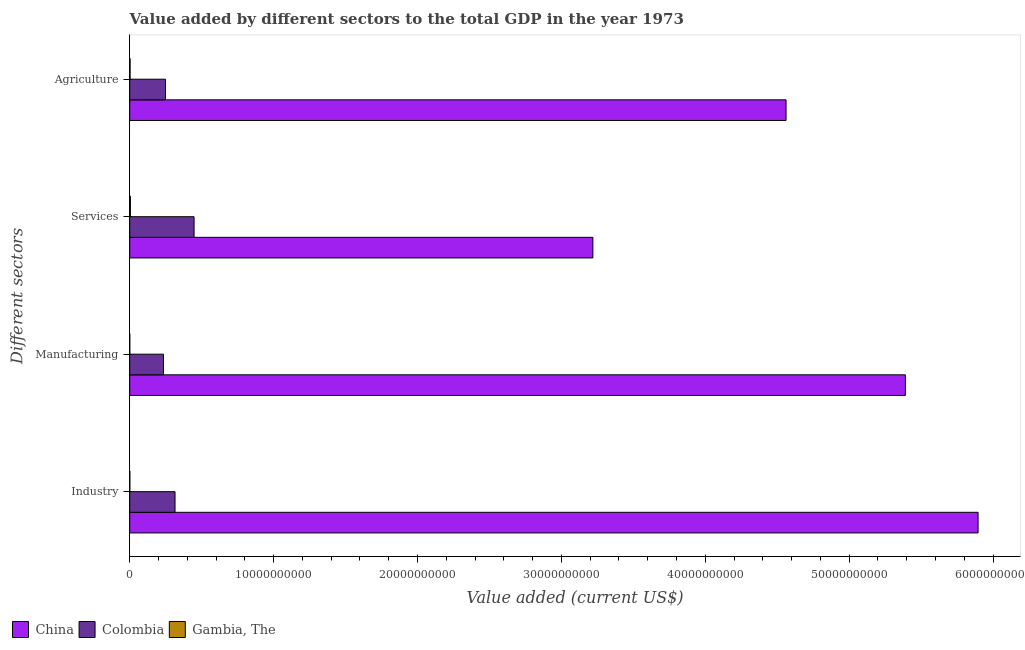How many different coloured bars are there?
Provide a succinct answer. 3. How many groups of bars are there?
Ensure brevity in your answer.  4. Are the number of bars on each tick of the Y-axis equal?
Offer a terse response. Yes. What is the label of the 2nd group of bars from the top?
Offer a terse response. Services. What is the value added by manufacturing sector in Gambia, The?
Your answer should be very brief. 2.20e+06. Across all countries, what is the maximum value added by agricultural sector?
Offer a very short reply. 4.56e+1. Across all countries, what is the minimum value added by agricultural sector?
Provide a succinct answer. 2.42e+07. In which country was the value added by manufacturing sector minimum?
Make the answer very short. Gambia, The. What is the total value added by manufacturing sector in the graph?
Your answer should be very brief. 5.63e+1. What is the difference between the value added by services sector in China and that in Colombia?
Give a very brief answer. 2.77e+1. What is the difference between the value added by manufacturing sector in Gambia, The and the value added by services sector in Colombia?
Make the answer very short. -4.47e+09. What is the average value added by industrial sector per country?
Offer a very short reply. 2.07e+1. What is the difference between the value added by agricultural sector and value added by services sector in Gambia, The?
Offer a very short reply. -2.05e+07. What is the ratio of the value added by manufacturing sector in Gambia, The to that in China?
Your answer should be very brief. 4.085952484394732e-5. Is the value added by manufacturing sector in Gambia, The less than that in China?
Make the answer very short. Yes. Is the difference between the value added by agricultural sector in Gambia, The and China greater than the difference between the value added by manufacturing sector in Gambia, The and China?
Provide a short and direct response. Yes. What is the difference between the highest and the second highest value added by services sector?
Keep it short and to the point. 2.77e+1. What is the difference between the highest and the lowest value added by agricultural sector?
Give a very brief answer. 4.56e+1. Is it the case that in every country, the sum of the value added by industrial sector and value added by manufacturing sector is greater than the value added by services sector?
Make the answer very short. No. How many bars are there?
Make the answer very short. 12. Are all the bars in the graph horizontal?
Make the answer very short. Yes. How many countries are there in the graph?
Provide a short and direct response. 3. What is the difference between two consecutive major ticks on the X-axis?
Your answer should be very brief. 1.00e+1. Does the graph contain any zero values?
Give a very brief answer. No. Does the graph contain grids?
Make the answer very short. No. Where does the legend appear in the graph?
Give a very brief answer. Bottom left. How many legend labels are there?
Provide a succinct answer. 3. What is the title of the graph?
Keep it short and to the point. Value added by different sectors to the total GDP in the year 1973. Does "Timor-Leste" appear as one of the legend labels in the graph?
Your answer should be very brief. No. What is the label or title of the X-axis?
Provide a succinct answer. Value added (current US$). What is the label or title of the Y-axis?
Give a very brief answer. Different sectors. What is the Value added (current US$) in China in Industry?
Offer a very short reply. 5.90e+1. What is the Value added (current US$) of Colombia in Industry?
Your answer should be very brief. 3.15e+09. What is the Value added (current US$) in Gambia, The in Industry?
Your answer should be very brief. 6.20e+06. What is the Value added (current US$) of China in Manufacturing?
Keep it short and to the point. 5.39e+1. What is the Value added (current US$) of Colombia in Manufacturing?
Your response must be concise. 2.34e+09. What is the Value added (current US$) of Gambia, The in Manufacturing?
Offer a terse response. 2.20e+06. What is the Value added (current US$) of China in Services?
Give a very brief answer. 3.22e+1. What is the Value added (current US$) of Colombia in Services?
Keep it short and to the point. 4.47e+09. What is the Value added (current US$) of Gambia, The in Services?
Give a very brief answer. 4.48e+07. What is the Value added (current US$) of China in Agriculture?
Keep it short and to the point. 4.56e+1. What is the Value added (current US$) of Colombia in Agriculture?
Keep it short and to the point. 2.49e+09. What is the Value added (current US$) of Gambia, The in Agriculture?
Provide a succinct answer. 2.42e+07. Across all Different sectors, what is the maximum Value added (current US$) of China?
Your answer should be compact. 5.90e+1. Across all Different sectors, what is the maximum Value added (current US$) of Colombia?
Provide a short and direct response. 4.47e+09. Across all Different sectors, what is the maximum Value added (current US$) of Gambia, The?
Offer a terse response. 4.48e+07. Across all Different sectors, what is the minimum Value added (current US$) in China?
Your answer should be very brief. 3.22e+1. Across all Different sectors, what is the minimum Value added (current US$) of Colombia?
Ensure brevity in your answer.  2.34e+09. Across all Different sectors, what is the minimum Value added (current US$) in Gambia, The?
Offer a very short reply. 2.20e+06. What is the total Value added (current US$) of China in the graph?
Provide a succinct answer. 1.91e+11. What is the total Value added (current US$) in Colombia in the graph?
Give a very brief answer. 1.25e+1. What is the total Value added (current US$) of Gambia, The in the graph?
Your answer should be very brief. 7.74e+07. What is the difference between the Value added (current US$) in China in Industry and that in Manufacturing?
Offer a very short reply. 5.05e+09. What is the difference between the Value added (current US$) of Colombia in Industry and that in Manufacturing?
Your answer should be compact. 8.04e+08. What is the difference between the Value added (current US$) in Gambia, The in Industry and that in Manufacturing?
Your response must be concise. 3.99e+06. What is the difference between the Value added (current US$) in China in Industry and that in Services?
Offer a very short reply. 2.68e+1. What is the difference between the Value added (current US$) in Colombia in Industry and that in Services?
Your answer should be compact. -1.32e+09. What is the difference between the Value added (current US$) in Gambia, The in Industry and that in Services?
Give a very brief answer. -3.86e+07. What is the difference between the Value added (current US$) in China in Industry and that in Agriculture?
Provide a short and direct response. 1.33e+1. What is the difference between the Value added (current US$) of Colombia in Industry and that in Agriculture?
Ensure brevity in your answer.  6.59e+08. What is the difference between the Value added (current US$) of Gambia, The in Industry and that in Agriculture?
Make the answer very short. -1.80e+07. What is the difference between the Value added (current US$) in China in Manufacturing and that in Services?
Provide a short and direct response. 2.17e+1. What is the difference between the Value added (current US$) in Colombia in Manufacturing and that in Services?
Give a very brief answer. -2.13e+09. What is the difference between the Value added (current US$) in Gambia, The in Manufacturing and that in Services?
Your answer should be compact. -4.26e+07. What is the difference between the Value added (current US$) of China in Manufacturing and that in Agriculture?
Give a very brief answer. 8.29e+09. What is the difference between the Value added (current US$) of Colombia in Manufacturing and that in Agriculture?
Offer a terse response. -1.45e+08. What is the difference between the Value added (current US$) in Gambia, The in Manufacturing and that in Agriculture?
Make the answer very short. -2.20e+07. What is the difference between the Value added (current US$) of China in Services and that in Agriculture?
Provide a short and direct response. -1.34e+1. What is the difference between the Value added (current US$) of Colombia in Services and that in Agriculture?
Offer a very short reply. 1.98e+09. What is the difference between the Value added (current US$) of Gambia, The in Services and that in Agriculture?
Provide a succinct answer. 2.05e+07. What is the difference between the Value added (current US$) of China in Industry and the Value added (current US$) of Colombia in Manufacturing?
Provide a short and direct response. 5.66e+1. What is the difference between the Value added (current US$) of China in Industry and the Value added (current US$) of Gambia, The in Manufacturing?
Provide a short and direct response. 5.90e+1. What is the difference between the Value added (current US$) in Colombia in Industry and the Value added (current US$) in Gambia, The in Manufacturing?
Offer a terse response. 3.15e+09. What is the difference between the Value added (current US$) of China in Industry and the Value added (current US$) of Colombia in Services?
Give a very brief answer. 5.45e+1. What is the difference between the Value added (current US$) in China in Industry and the Value added (current US$) in Gambia, The in Services?
Your answer should be compact. 5.89e+1. What is the difference between the Value added (current US$) of Colombia in Industry and the Value added (current US$) of Gambia, The in Services?
Keep it short and to the point. 3.10e+09. What is the difference between the Value added (current US$) of China in Industry and the Value added (current US$) of Colombia in Agriculture?
Provide a short and direct response. 5.65e+1. What is the difference between the Value added (current US$) of China in Industry and the Value added (current US$) of Gambia, The in Agriculture?
Offer a very short reply. 5.89e+1. What is the difference between the Value added (current US$) of Colombia in Industry and the Value added (current US$) of Gambia, The in Agriculture?
Provide a short and direct response. 3.12e+09. What is the difference between the Value added (current US$) of China in Manufacturing and the Value added (current US$) of Colombia in Services?
Provide a short and direct response. 4.94e+1. What is the difference between the Value added (current US$) of China in Manufacturing and the Value added (current US$) of Gambia, The in Services?
Offer a terse response. 5.39e+1. What is the difference between the Value added (current US$) in Colombia in Manufacturing and the Value added (current US$) in Gambia, The in Services?
Ensure brevity in your answer.  2.30e+09. What is the difference between the Value added (current US$) in China in Manufacturing and the Value added (current US$) in Colombia in Agriculture?
Your response must be concise. 5.14e+1. What is the difference between the Value added (current US$) of China in Manufacturing and the Value added (current US$) of Gambia, The in Agriculture?
Ensure brevity in your answer.  5.39e+1. What is the difference between the Value added (current US$) of Colombia in Manufacturing and the Value added (current US$) of Gambia, The in Agriculture?
Your answer should be very brief. 2.32e+09. What is the difference between the Value added (current US$) of China in Services and the Value added (current US$) of Colombia in Agriculture?
Keep it short and to the point. 2.97e+1. What is the difference between the Value added (current US$) in China in Services and the Value added (current US$) in Gambia, The in Agriculture?
Offer a terse response. 3.22e+1. What is the difference between the Value added (current US$) in Colombia in Services and the Value added (current US$) in Gambia, The in Agriculture?
Make the answer very short. 4.45e+09. What is the average Value added (current US$) in China per Different sectors?
Your answer should be compact. 4.77e+1. What is the average Value added (current US$) of Colombia per Different sectors?
Your answer should be very brief. 3.11e+09. What is the average Value added (current US$) of Gambia, The per Different sectors?
Ensure brevity in your answer.  1.93e+07. What is the difference between the Value added (current US$) of China and Value added (current US$) of Colombia in Industry?
Your answer should be very brief. 5.58e+1. What is the difference between the Value added (current US$) of China and Value added (current US$) of Gambia, The in Industry?
Provide a short and direct response. 5.90e+1. What is the difference between the Value added (current US$) in Colombia and Value added (current US$) in Gambia, The in Industry?
Offer a terse response. 3.14e+09. What is the difference between the Value added (current US$) in China and Value added (current US$) in Colombia in Manufacturing?
Provide a succinct answer. 5.16e+1. What is the difference between the Value added (current US$) in China and Value added (current US$) in Gambia, The in Manufacturing?
Your answer should be very brief. 5.39e+1. What is the difference between the Value added (current US$) of Colombia and Value added (current US$) of Gambia, The in Manufacturing?
Provide a succinct answer. 2.34e+09. What is the difference between the Value added (current US$) of China and Value added (current US$) of Colombia in Services?
Give a very brief answer. 2.77e+1. What is the difference between the Value added (current US$) of China and Value added (current US$) of Gambia, The in Services?
Ensure brevity in your answer.  3.21e+1. What is the difference between the Value added (current US$) of Colombia and Value added (current US$) of Gambia, The in Services?
Make the answer very short. 4.43e+09. What is the difference between the Value added (current US$) in China and Value added (current US$) in Colombia in Agriculture?
Provide a succinct answer. 4.31e+1. What is the difference between the Value added (current US$) of China and Value added (current US$) of Gambia, The in Agriculture?
Ensure brevity in your answer.  4.56e+1. What is the difference between the Value added (current US$) in Colombia and Value added (current US$) in Gambia, The in Agriculture?
Your response must be concise. 2.46e+09. What is the ratio of the Value added (current US$) in China in Industry to that in Manufacturing?
Provide a succinct answer. 1.09. What is the ratio of the Value added (current US$) in Colombia in Industry to that in Manufacturing?
Offer a very short reply. 1.34. What is the ratio of the Value added (current US$) of Gambia, The in Industry to that in Manufacturing?
Provide a short and direct response. 2.81. What is the ratio of the Value added (current US$) in China in Industry to that in Services?
Make the answer very short. 1.83. What is the ratio of the Value added (current US$) of Colombia in Industry to that in Services?
Provide a short and direct response. 0.7. What is the ratio of the Value added (current US$) in Gambia, The in Industry to that in Services?
Your answer should be compact. 0.14. What is the ratio of the Value added (current US$) of China in Industry to that in Agriculture?
Your response must be concise. 1.29. What is the ratio of the Value added (current US$) in Colombia in Industry to that in Agriculture?
Your answer should be very brief. 1.26. What is the ratio of the Value added (current US$) in Gambia, The in Industry to that in Agriculture?
Provide a succinct answer. 0.26. What is the ratio of the Value added (current US$) in China in Manufacturing to that in Services?
Offer a terse response. 1.67. What is the ratio of the Value added (current US$) of Colombia in Manufacturing to that in Services?
Keep it short and to the point. 0.52. What is the ratio of the Value added (current US$) in Gambia, The in Manufacturing to that in Services?
Your answer should be very brief. 0.05. What is the ratio of the Value added (current US$) in China in Manufacturing to that in Agriculture?
Keep it short and to the point. 1.18. What is the ratio of the Value added (current US$) in Colombia in Manufacturing to that in Agriculture?
Offer a terse response. 0.94. What is the ratio of the Value added (current US$) of Gambia, The in Manufacturing to that in Agriculture?
Your answer should be very brief. 0.09. What is the ratio of the Value added (current US$) in China in Services to that in Agriculture?
Make the answer very short. 0.71. What is the ratio of the Value added (current US$) of Colombia in Services to that in Agriculture?
Give a very brief answer. 1.8. What is the ratio of the Value added (current US$) in Gambia, The in Services to that in Agriculture?
Give a very brief answer. 1.85. What is the difference between the highest and the second highest Value added (current US$) in China?
Provide a short and direct response. 5.05e+09. What is the difference between the highest and the second highest Value added (current US$) in Colombia?
Your answer should be very brief. 1.32e+09. What is the difference between the highest and the second highest Value added (current US$) of Gambia, The?
Give a very brief answer. 2.05e+07. What is the difference between the highest and the lowest Value added (current US$) of China?
Provide a succinct answer. 2.68e+1. What is the difference between the highest and the lowest Value added (current US$) of Colombia?
Your answer should be compact. 2.13e+09. What is the difference between the highest and the lowest Value added (current US$) in Gambia, The?
Provide a succinct answer. 4.26e+07. 